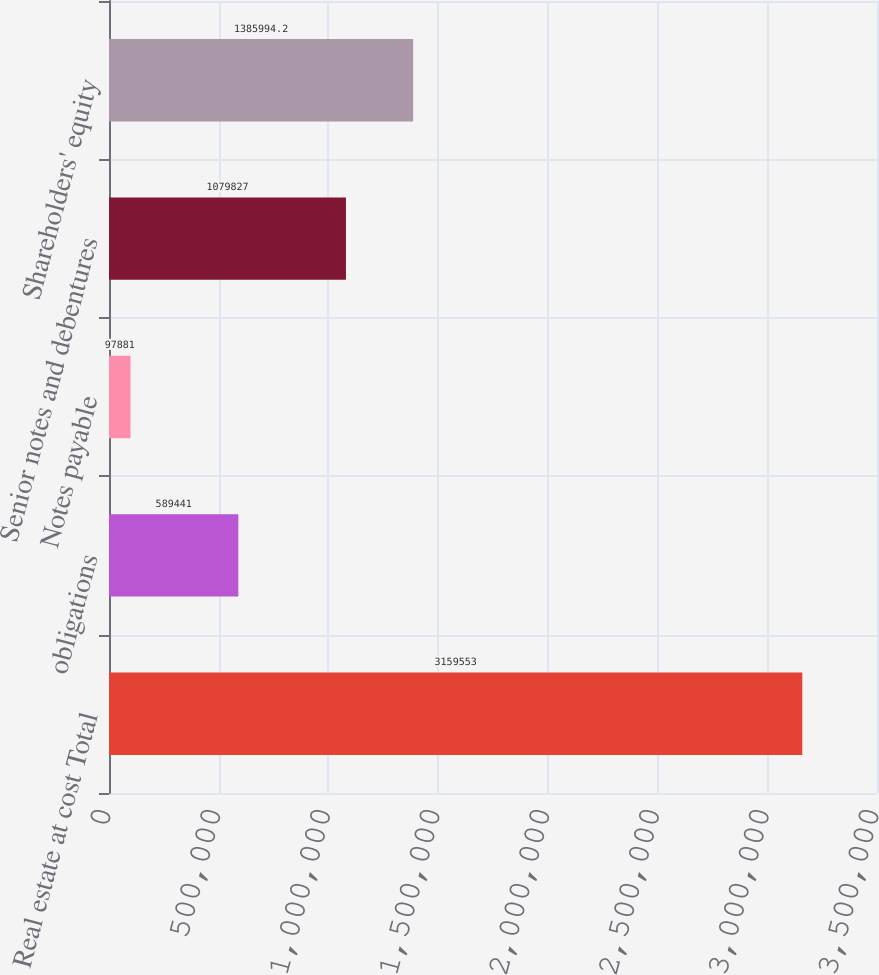<chart> <loc_0><loc_0><loc_500><loc_500><bar_chart><fcel>Real estate at cost Total<fcel>obligations<fcel>Notes payable<fcel>Senior notes and debentures<fcel>Shareholders' equity<nl><fcel>3.15955e+06<fcel>589441<fcel>97881<fcel>1.07983e+06<fcel>1.38599e+06<nl></chart> 